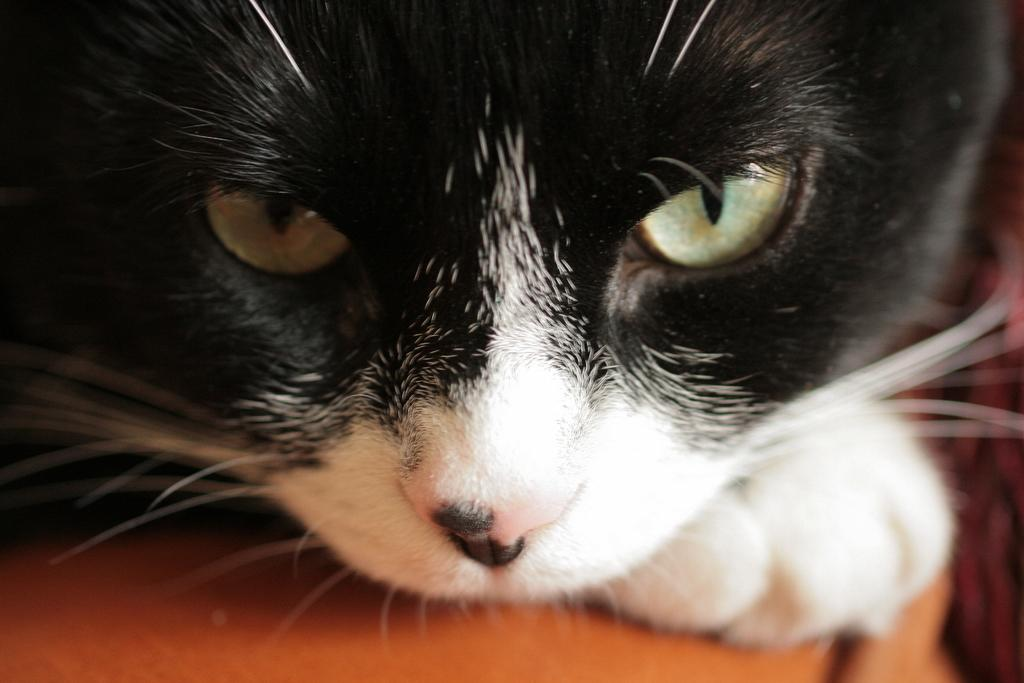What type of animal is in the image? There is a cat in the image. Where is the cat located in the image? The cat is on a surface. What type of love story is being told in the image? There is no love story present in the image, as it only features a cat on a surface. 